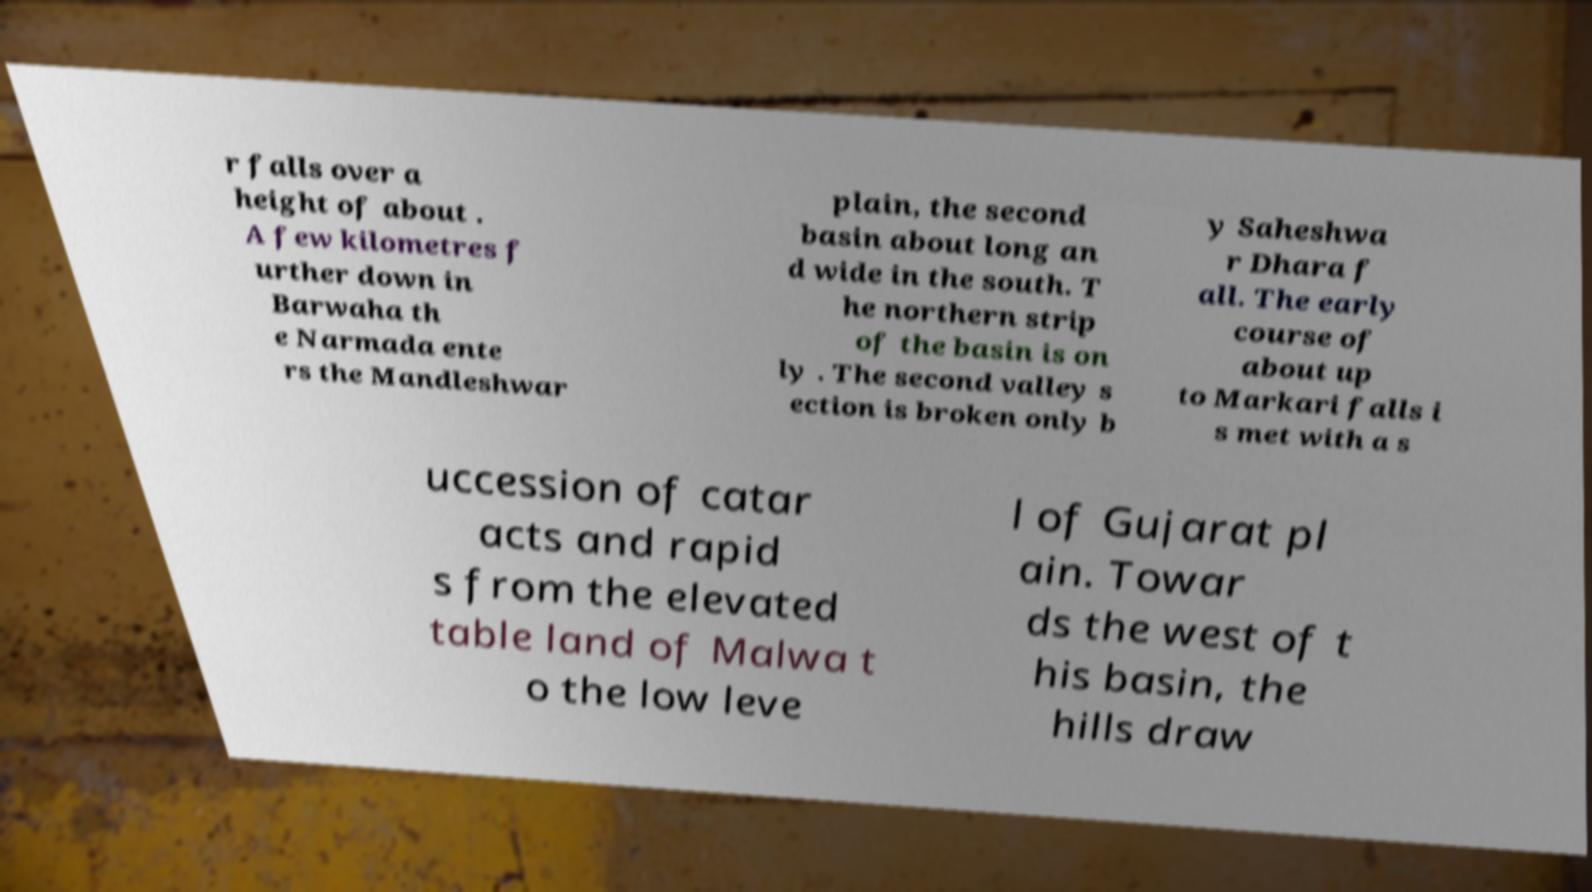Could you assist in decoding the text presented in this image and type it out clearly? r falls over a height of about . A few kilometres f urther down in Barwaha th e Narmada ente rs the Mandleshwar plain, the second basin about long an d wide in the south. T he northern strip of the basin is on ly . The second valley s ection is broken only b y Saheshwa r Dhara f all. The early course of about up to Markari falls i s met with a s uccession of catar acts and rapid s from the elevated table land of Malwa t o the low leve l of Gujarat pl ain. Towar ds the west of t his basin, the hills draw 